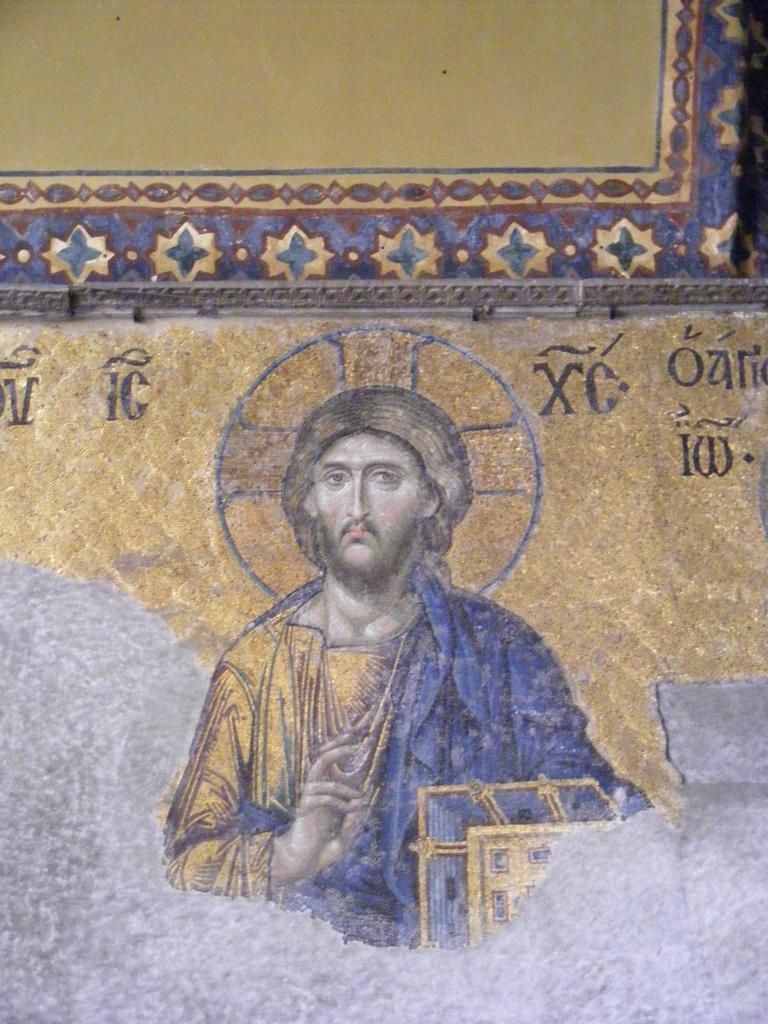What is depicted in the painting in the image? There is a painting of a person in the image. What else can be seen in the image besides the painting? There are designs and text on a plain wall in the image. What type of celery is being used as a neck scarf in the image? There is no celery or neck scarf present in the image. 